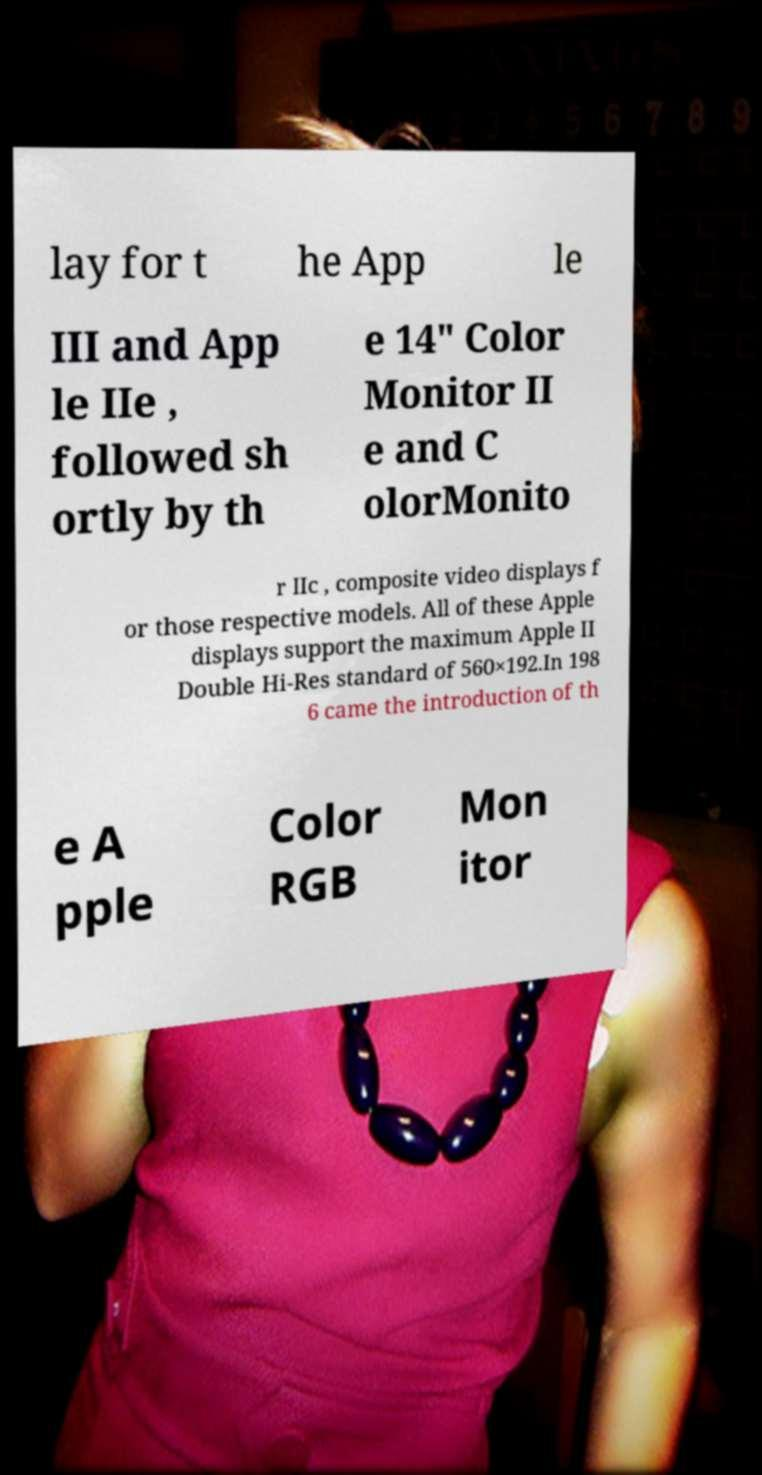There's text embedded in this image that I need extracted. Can you transcribe it verbatim? lay for t he App le III and App le IIe , followed sh ortly by th e 14″ Color Monitor II e and C olorMonito r IIc , composite video displays f or those respective models. All of these Apple displays support the maximum Apple II Double Hi-Res standard of 560×192.In 198 6 came the introduction of th e A pple Color RGB Mon itor 